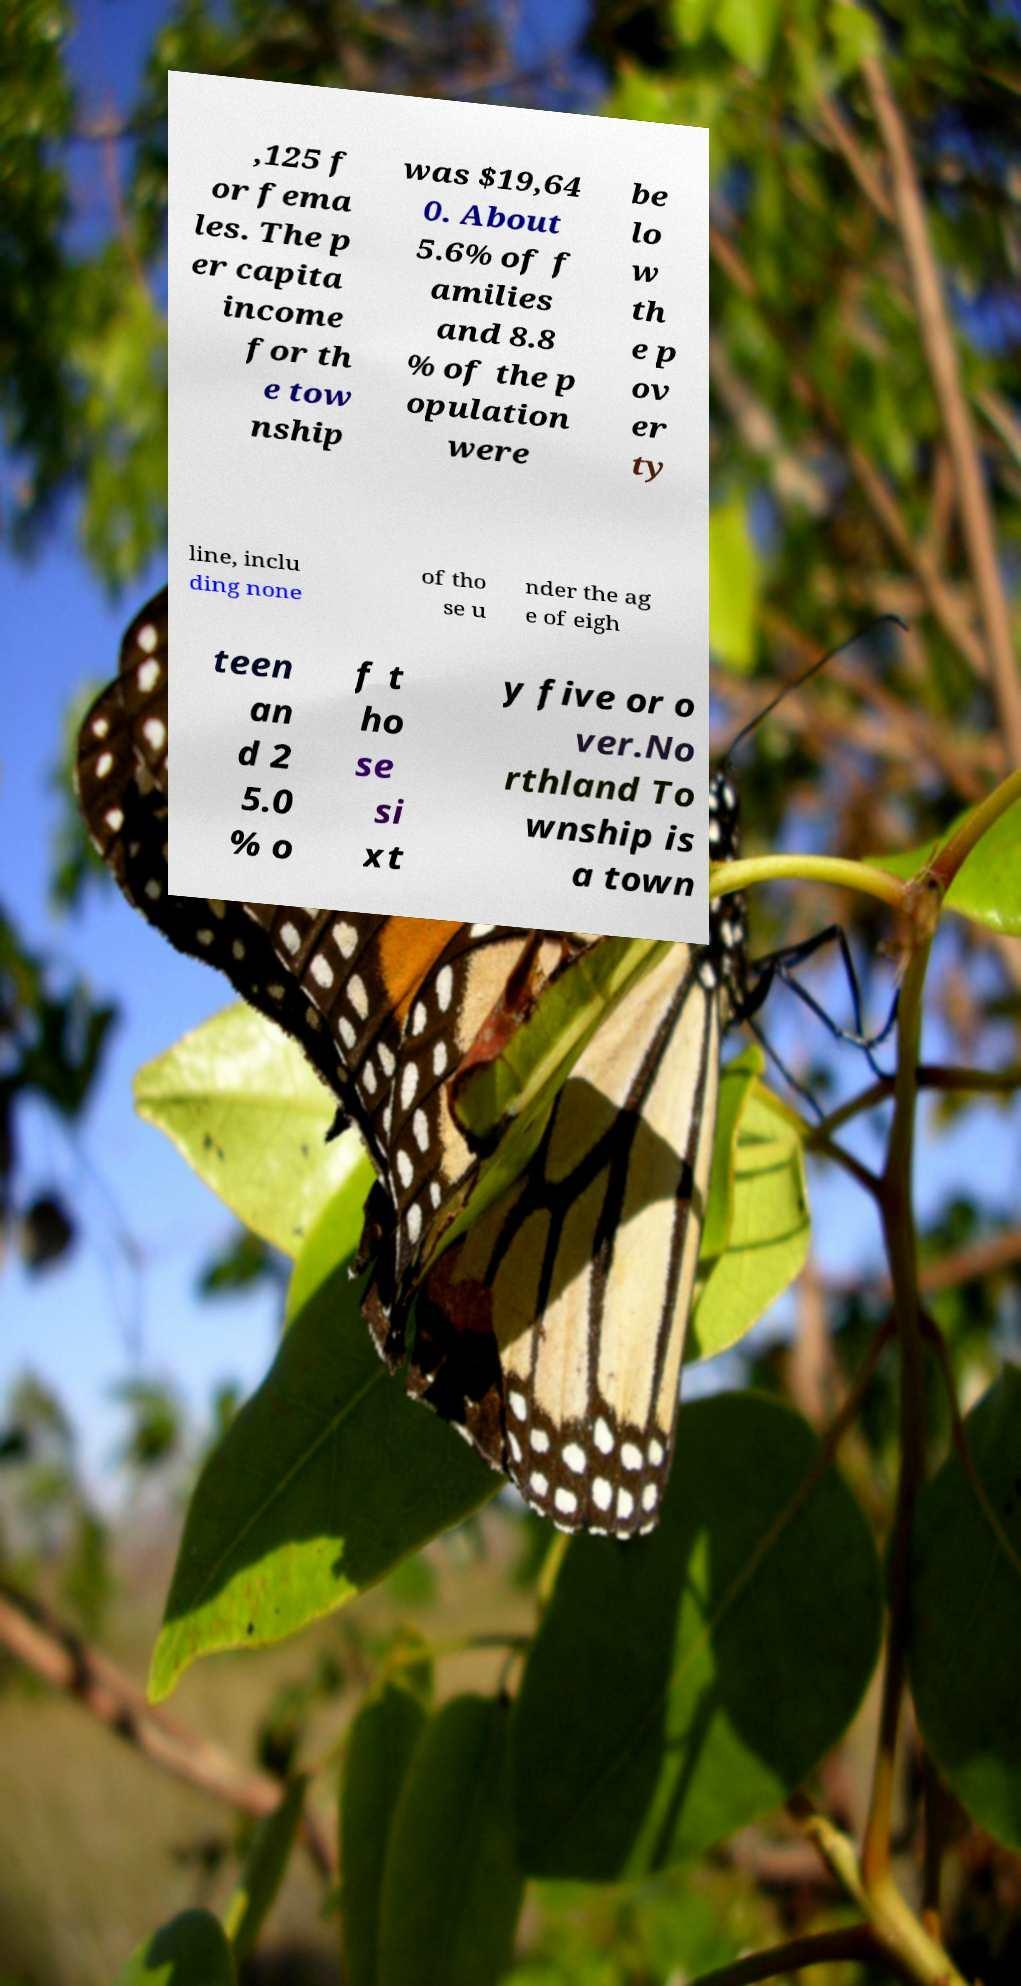Could you assist in decoding the text presented in this image and type it out clearly? ,125 f or fema les. The p er capita income for th e tow nship was $19,64 0. About 5.6% of f amilies and 8.8 % of the p opulation were be lo w th e p ov er ty line, inclu ding none of tho se u nder the ag e of eigh teen an d 2 5.0 % o f t ho se si xt y five or o ver.No rthland To wnship is a town 